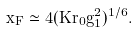Convert formula to latex. <formula><loc_0><loc_0><loc_500><loc_500>x _ { F } \simeq 4 ( K r _ { 0 } g _ { 1 } ^ { 2 } ) ^ { 1 / 6 } .</formula> 